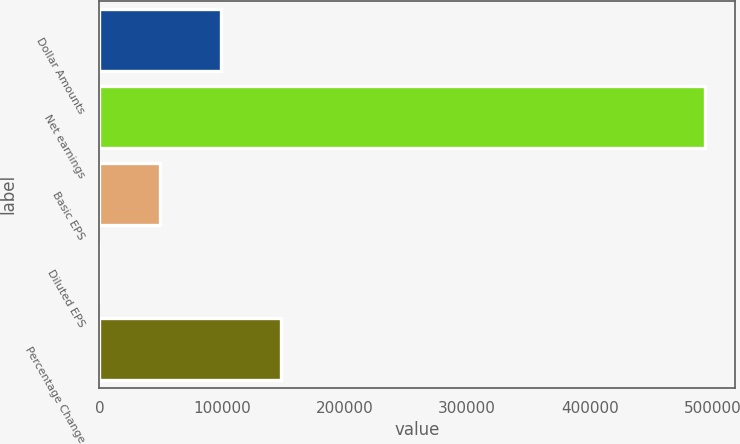<chart> <loc_0><loc_0><loc_500><loc_500><bar_chart><fcel>Dollar Amounts<fcel>Net earnings<fcel>Basic EPS<fcel>Diluted EPS<fcel>Percentage Change<nl><fcel>98831.3<fcel>494150<fcel>49416.5<fcel>1.66<fcel>148246<nl></chart> 